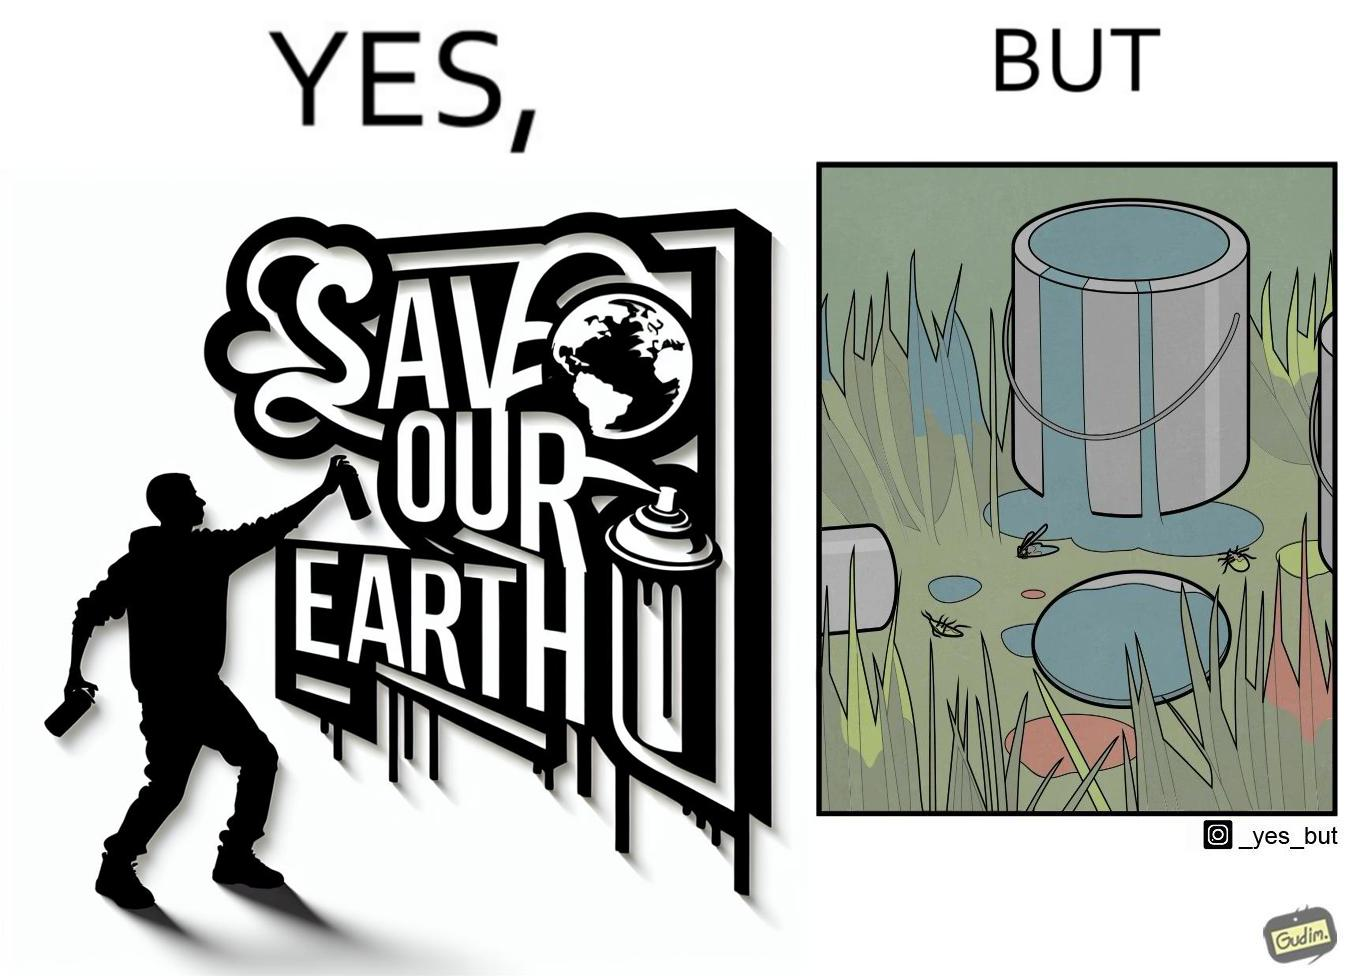Explain why this image is satirical. The image is ironical, as the cans of paint used to make graffiti on the theme "Save the Earth" seems to be destroying the Earth when it overflows on the grass, as it is harmful for the flora and fauna, as can be seen from the dying insects. 